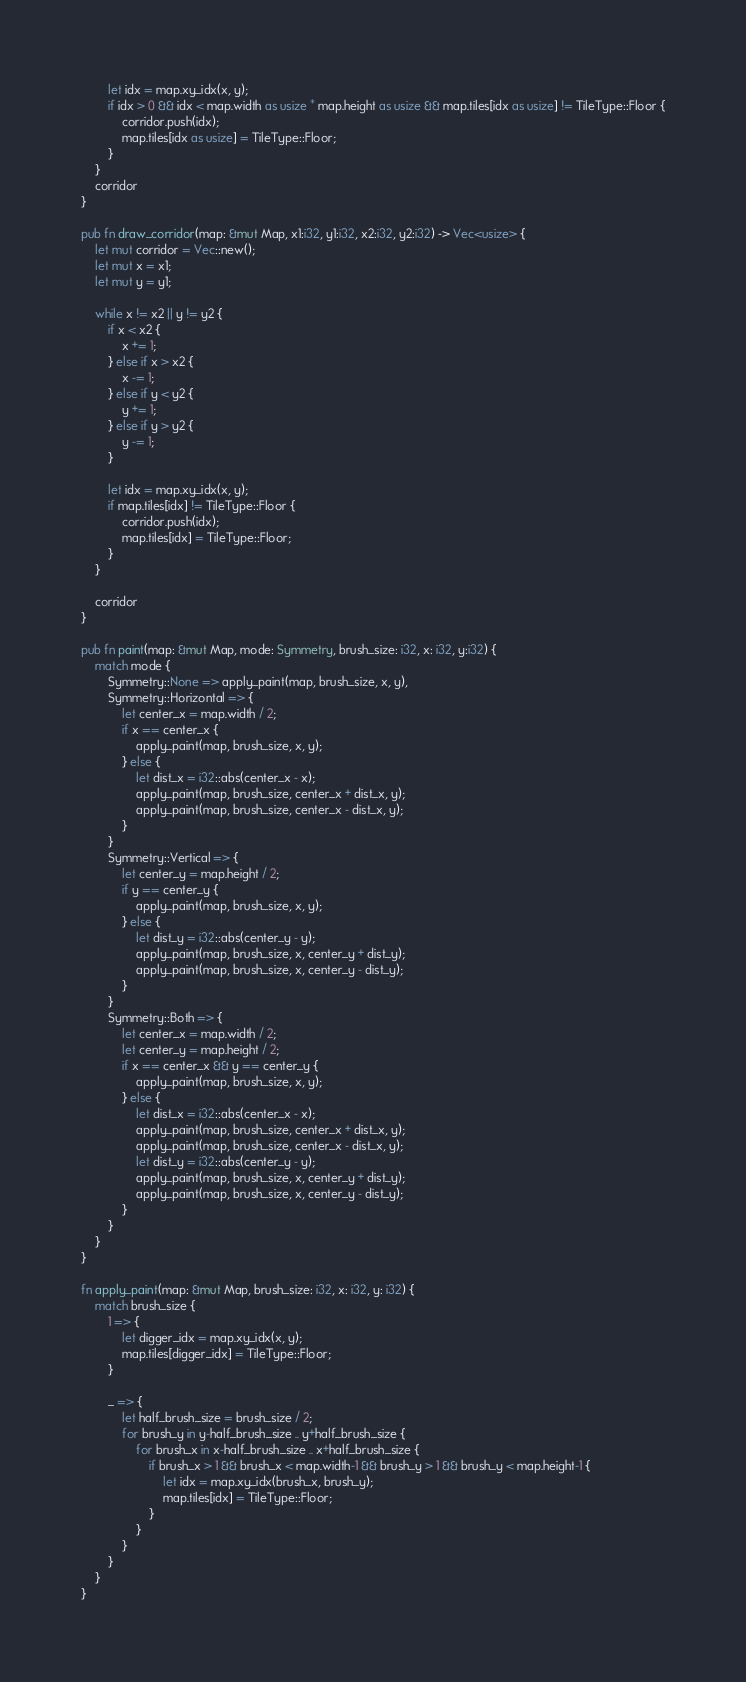<code> <loc_0><loc_0><loc_500><loc_500><_Rust_>        let idx = map.xy_idx(x, y);
        if idx > 0 && idx < map.width as usize * map.height as usize && map.tiles[idx as usize] != TileType::Floor {
            corridor.push(idx);
            map.tiles[idx as usize] = TileType::Floor;
        }
    }
    corridor
}

pub fn draw_corridor(map: &mut Map, x1:i32, y1:i32, x2:i32, y2:i32) -> Vec<usize> {
    let mut corridor = Vec::new();
    let mut x = x1;
    let mut y = y1;

    while x != x2 || y != y2 {
        if x < x2 {
            x += 1;
        } else if x > x2 {
            x -= 1;
        } else if y < y2 {
            y += 1;
        } else if y > y2 {
            y -= 1;
        }

        let idx = map.xy_idx(x, y);
        if map.tiles[idx] != TileType::Floor {
            corridor.push(idx);
            map.tiles[idx] = TileType::Floor;
        }
    }

    corridor
}

pub fn paint(map: &mut Map, mode: Symmetry, brush_size: i32, x: i32, y:i32) {
    match mode {
        Symmetry::None => apply_paint(map, brush_size, x, y),
        Symmetry::Horizontal => {
            let center_x = map.width / 2;
            if x == center_x {
                apply_paint(map, brush_size, x, y);                    
            } else {
                let dist_x = i32::abs(center_x - x);
                apply_paint(map, brush_size, center_x + dist_x, y);
                apply_paint(map, brush_size, center_x - dist_x, y);
            }
        }
        Symmetry::Vertical => {
            let center_y = map.height / 2;
            if y == center_y {
                apply_paint(map, brush_size, x, y);
            } else {
                let dist_y = i32::abs(center_y - y);
                apply_paint(map, brush_size, x, center_y + dist_y);
                apply_paint(map, brush_size, x, center_y - dist_y);
            }
        }
        Symmetry::Both => {
            let center_x = map.width / 2;
            let center_y = map.height / 2;
            if x == center_x && y == center_y {
                apply_paint(map, brush_size, x, y);
            } else {
                let dist_x = i32::abs(center_x - x);
                apply_paint(map, brush_size, center_x + dist_x, y);
                apply_paint(map, brush_size, center_x - dist_x, y);
                let dist_y = i32::abs(center_y - y);
                apply_paint(map, brush_size, x, center_y + dist_y);
                apply_paint(map, brush_size, x, center_y - dist_y);
            }
        }
    }
}

fn apply_paint(map: &mut Map, brush_size: i32, x: i32, y: i32) {
    match brush_size {
        1 => {
            let digger_idx = map.xy_idx(x, y);
            map.tiles[digger_idx] = TileType::Floor;
        }

        _ => {
            let half_brush_size = brush_size / 2;
            for brush_y in y-half_brush_size .. y+half_brush_size {
                for brush_x in x-half_brush_size .. x+half_brush_size {
                    if brush_x > 1 && brush_x < map.width-1 && brush_y > 1 && brush_y < map.height-1 {
                        let idx = map.xy_idx(brush_x, brush_y);
                        map.tiles[idx] = TileType::Floor;
                    }
                }
            }
        }
    }
}</code> 